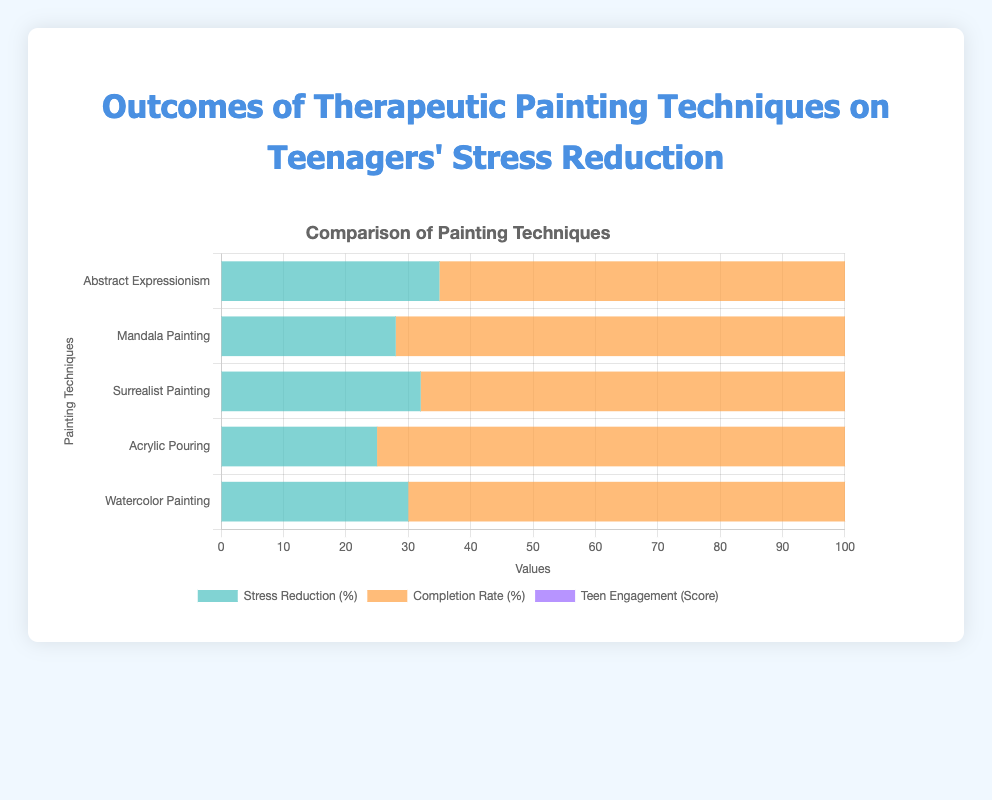What painting technique has the highest average stress reduction? By visually examining the heights of the bars for stress reduction values, Abstract Expressionism is the tallest, indicating it has the highest average stress reduction.
Answer: Abstract Expressionism Which painting technique has the lowest teen engagement score? By comparing the purple-colored bars representing teen engagement scores, Surrealist Painting has the lowest average score.
Answer: Surrealist Painting What is the average completion rate for Watercolor Painting and Abstract Expressionism combined? The completion rates are 85% for Watercolor Painting and 87% for Abstract Expressionism. Averaging these: (85 + 87) / 2 = 86%
Answer: 86% Which technique shows the largest variation in stress reduction? Looking at the range (max - min) for each technique's stress reduction, Mandala Painting varies from 15% to 40%, which is the largest range (25%).
Answer: Mandala Painting Is the completion rate for Mandala Painting greater than that for Surrealist Painting? The bar for the completion rate of Mandala Painting is higher than that for Surrealist Painting, indicating that it is indeed higher.
Answer: Yes For Acrylic Pouring, how does the average teen engagement score compare to the average completion rate? Acrylic Pouring has an average teen engagement score of 4.5 and a completion rate of 88%. Comparing these directly: 4.5 is, of course, less than 88%.
Answer: Less than What is the total stress reduction improvement for Surrealist Painting and Mandala Painting combined? The average stress reductions are 32% for Surrealist Painting and 28% for Mandala Painting. Adding these: 32 + 28 = 60%
Answer: 60% Which technique has the highest average completion rate? By visually inspecting heights of the orange-colored bars for completion rates, Mandala Painting stands out as the highest.
Answer: Mandala Painting 